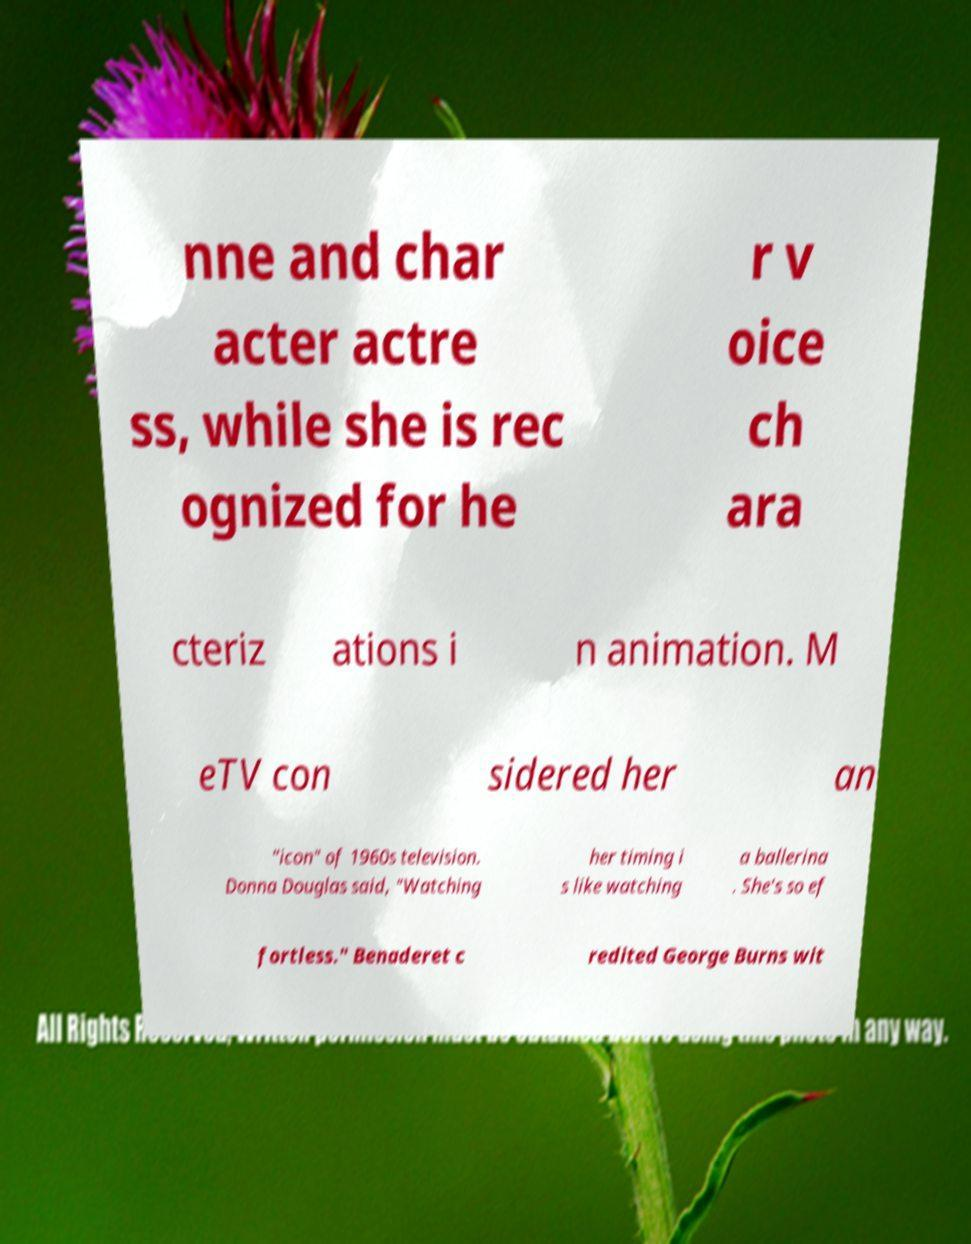For documentation purposes, I need the text within this image transcribed. Could you provide that? nne and char acter actre ss, while she is rec ognized for he r v oice ch ara cteriz ations i n animation. M eTV con sidered her an "icon" of 1960s television. Donna Douglas said, "Watching her timing i s like watching a ballerina . She's so ef fortless." Benaderet c redited George Burns wit 